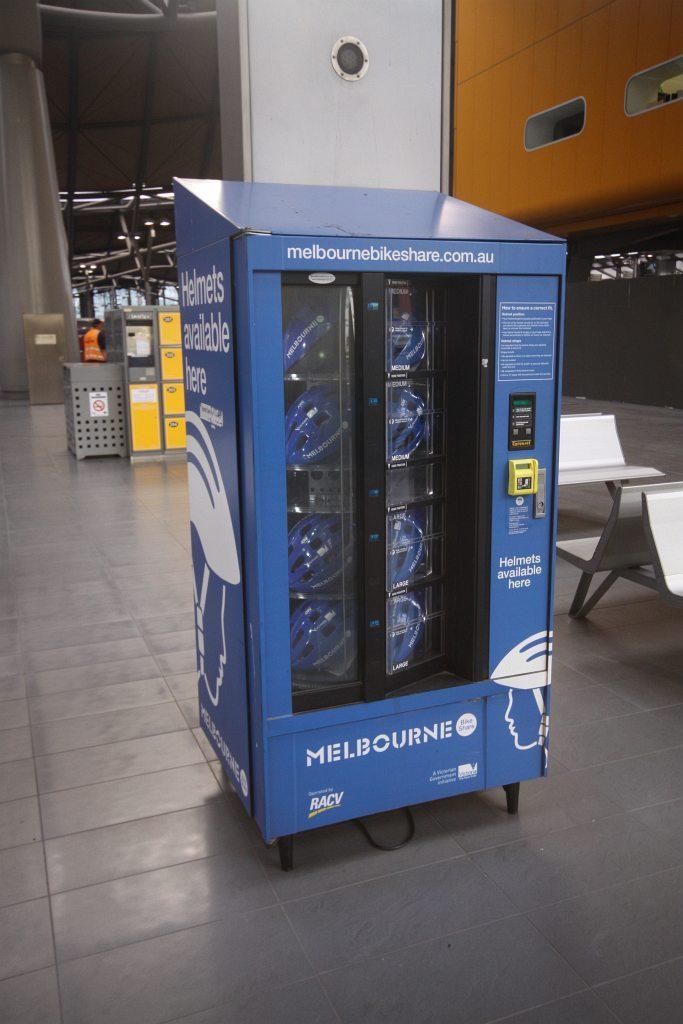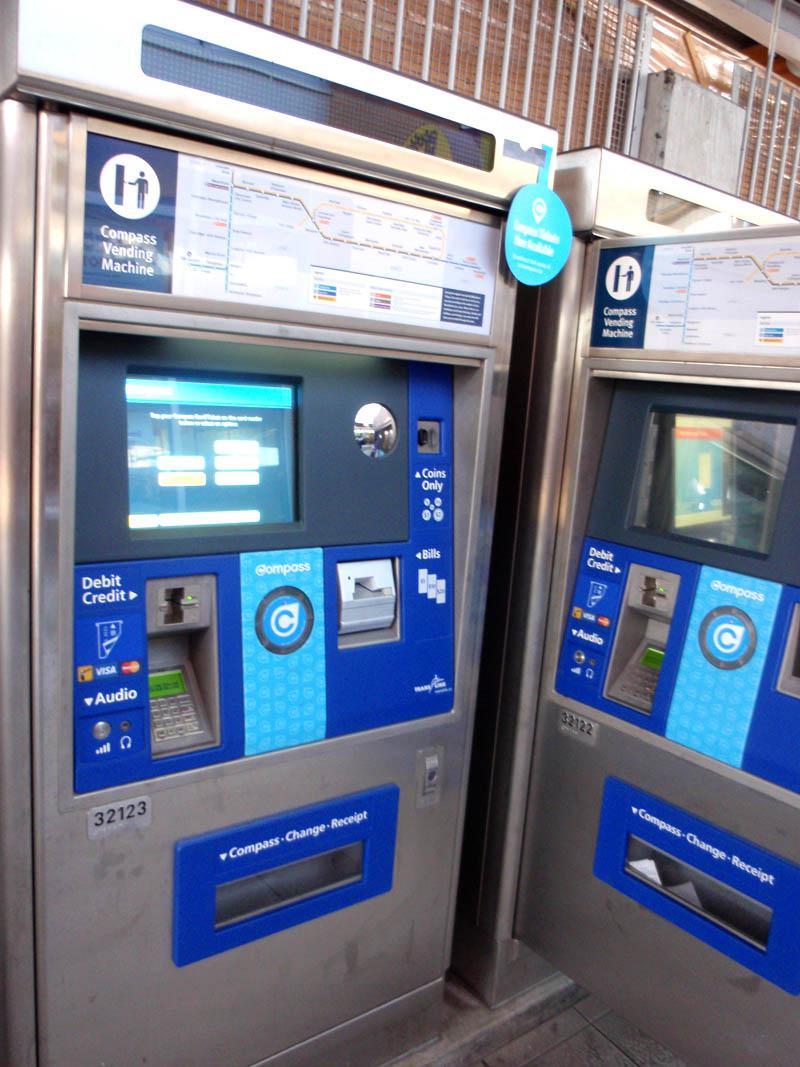The first image is the image on the left, the second image is the image on the right. For the images displayed, is the sentence "There is a at least one person in the image on the left." factually correct? Answer yes or no. No. 